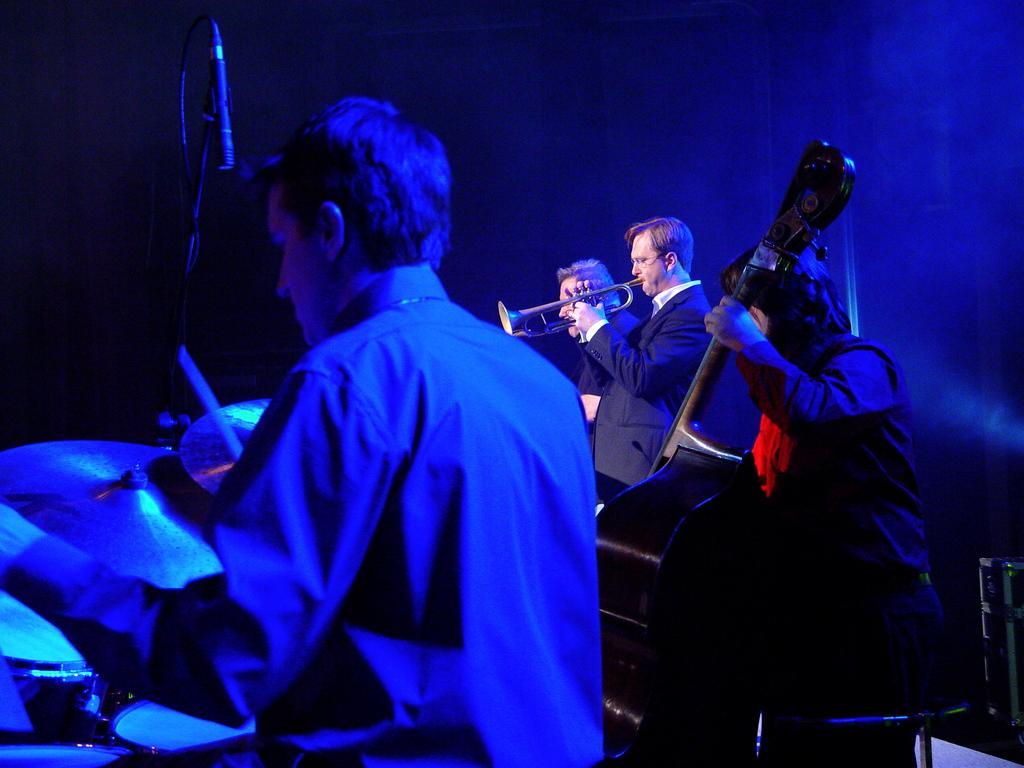Can you describe this image briefly? In this image, I can see four people playing the musical instruments. On the left side of the image, I can see a mike with a mike stand. The background looks blue and black in color. 